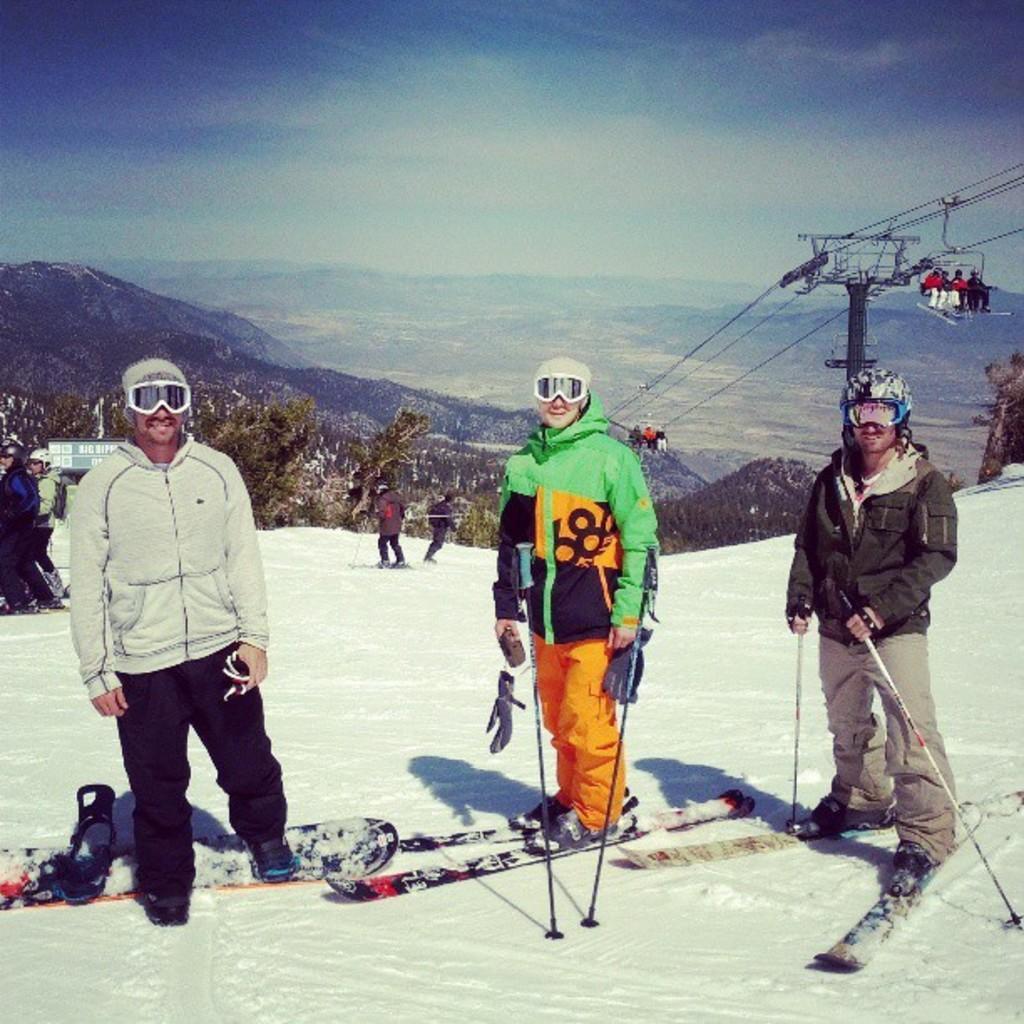Can you describe this image briefly? The picture looks like it is clicked near the Himalayas and here there is mountain, trees, snow and the sky. There are three persons standing in front and they are wearing snow jackets. The man to the left is wearing white colored jacket, the person in the middle is wearing a green colored jacket, the man to the right is wearing brown colored jacket. There is Rope way here, there are few people travelling through the ropeway. 